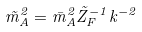Convert formula to latex. <formula><loc_0><loc_0><loc_500><loc_500>\tilde { m } ^ { 2 } _ { A } = \bar { m } ^ { 2 } _ { A } \tilde { Z } _ { F } ^ { - 1 } k ^ { - 2 }</formula> 